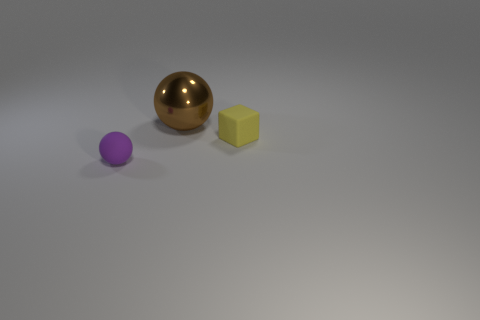Are there fewer tiny rubber blocks than tiny objects? Upon reviewing the image, it appears that there is a single tiny rubber block visible, along with two other objects of different shapes, making the total number of tiny objects three. Therefore, it can be concluded that there are indeed fewer tiny rubber blocks than tiny objects in the image. 